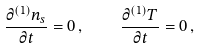Convert formula to latex. <formula><loc_0><loc_0><loc_500><loc_500>\frac { \partial ^ { ( 1 ) } n _ { s } } { \partial t } = 0 \, , \quad \frac { \partial ^ { ( 1 ) } T } { \partial t } = 0 \, ,</formula> 